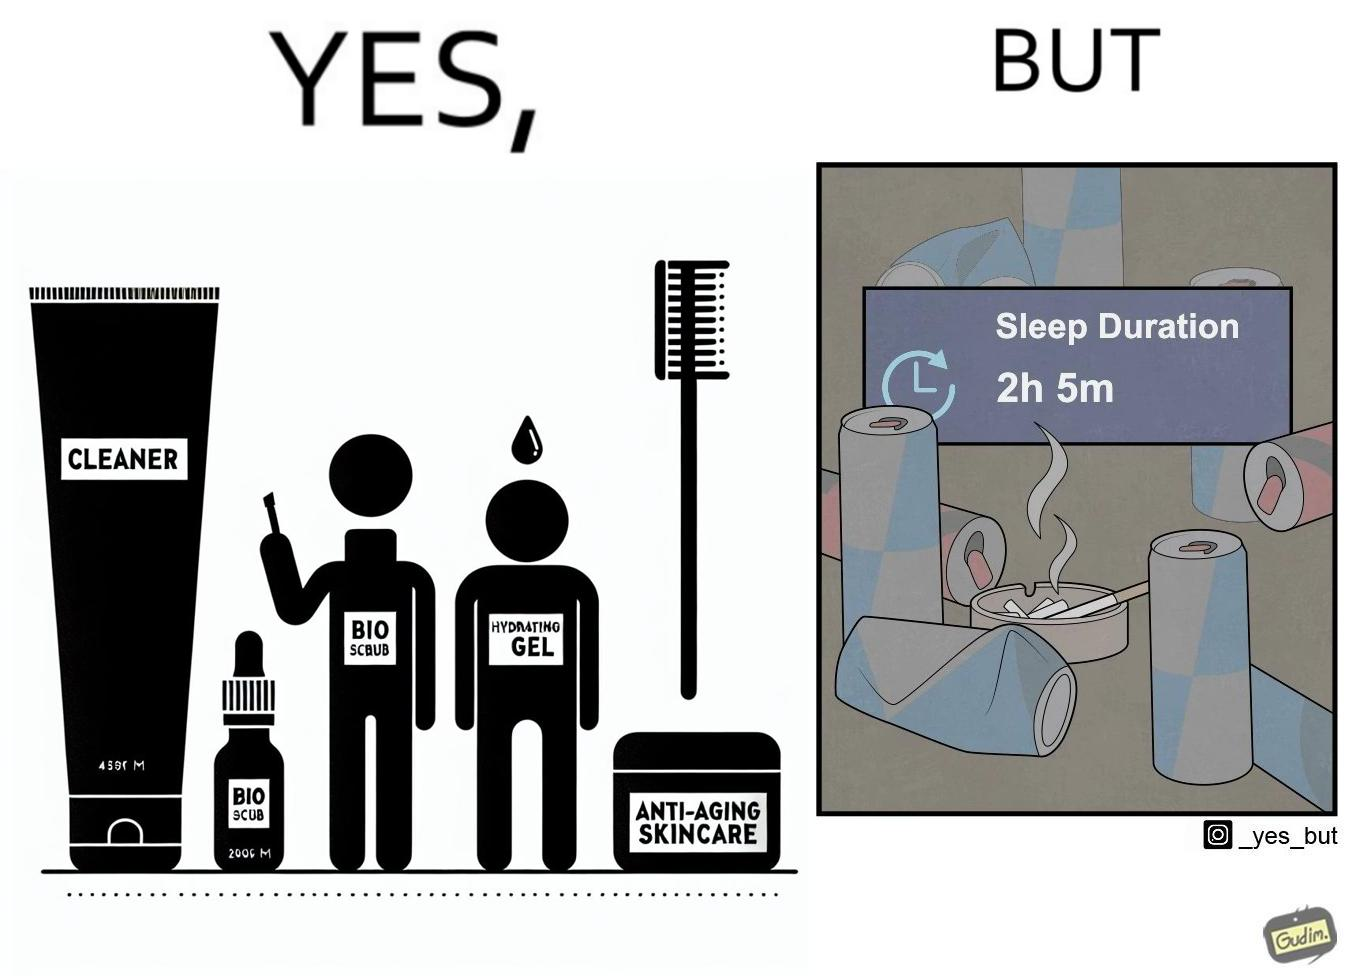What is the satirical meaning behind this image? This image is ironic as on the one hand, the presumed person is into skincare and wants to do the best for their skin, which is good, but on the other hand, they are involved in unhealthy habits that will damage their skin like smoking, caffeine and inadequate sleep. 